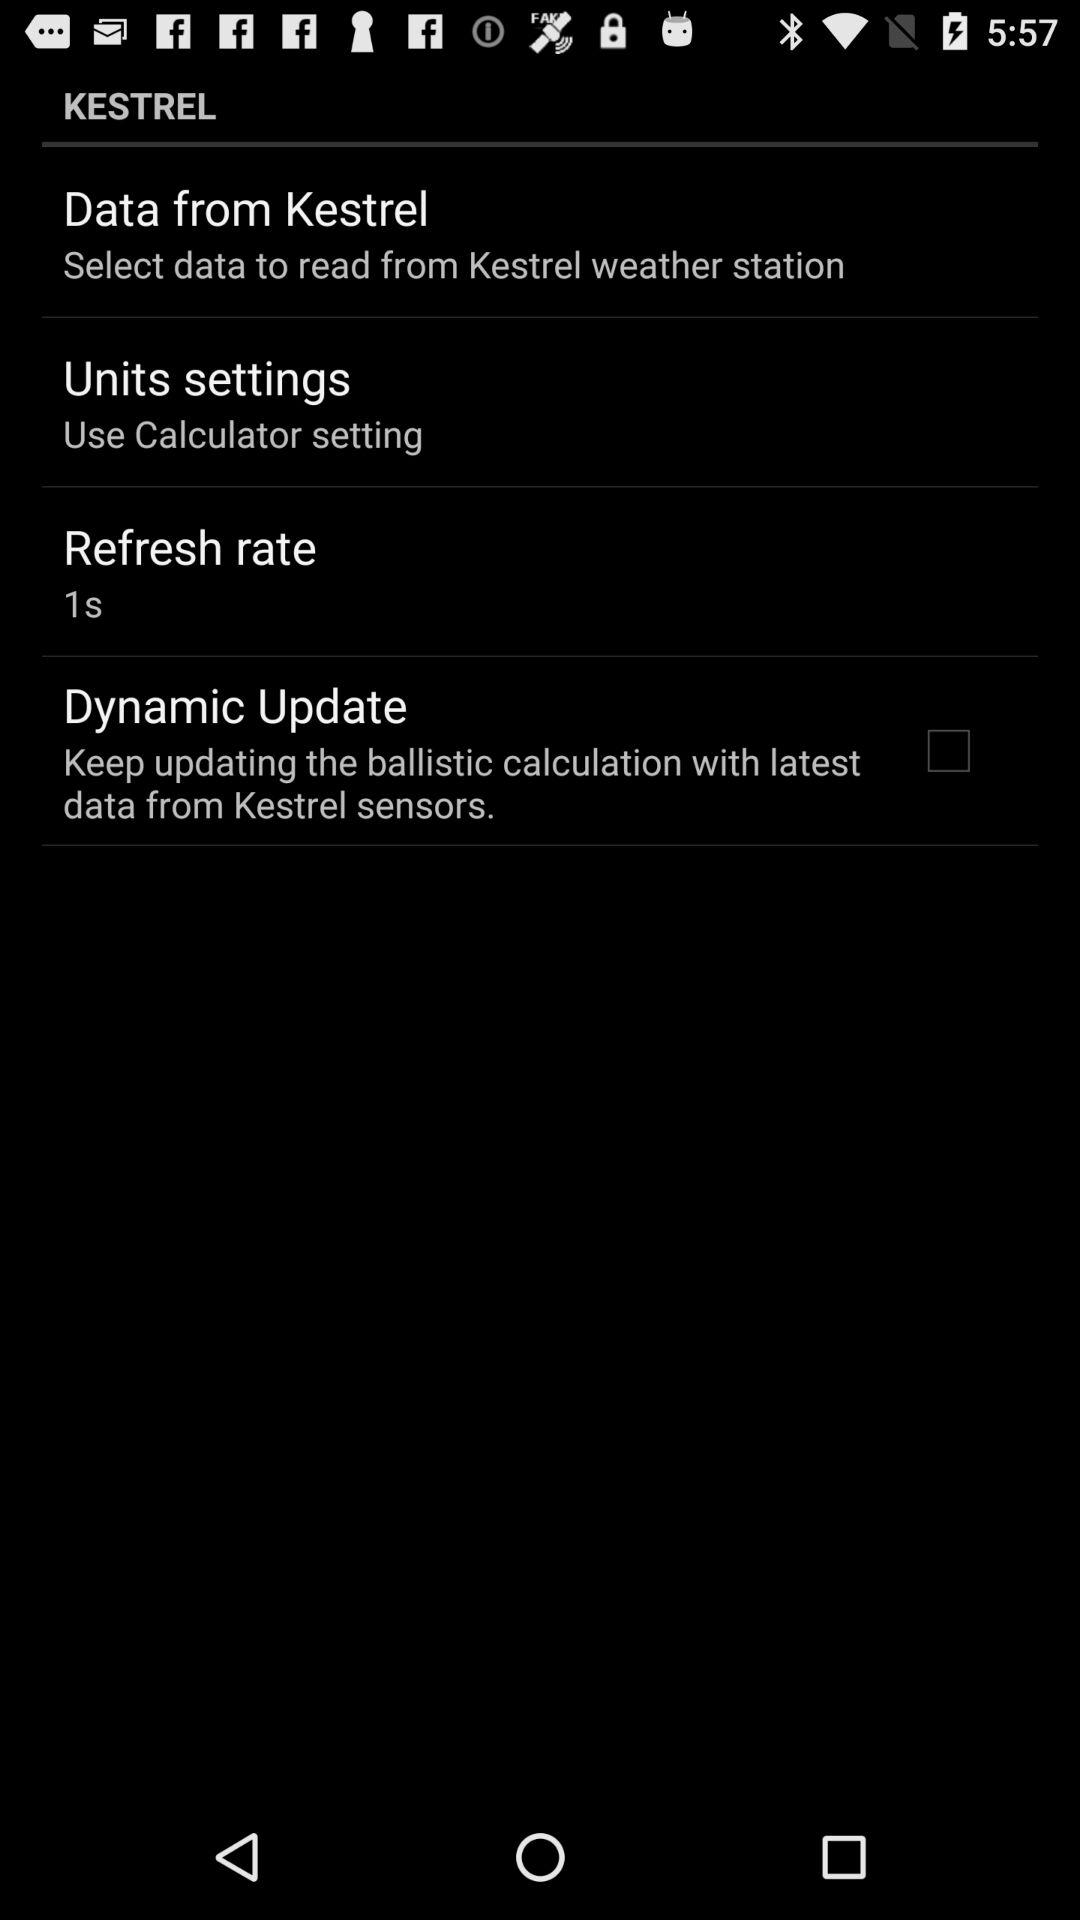What is the refresh rate? The refresh rate is 1 second. 